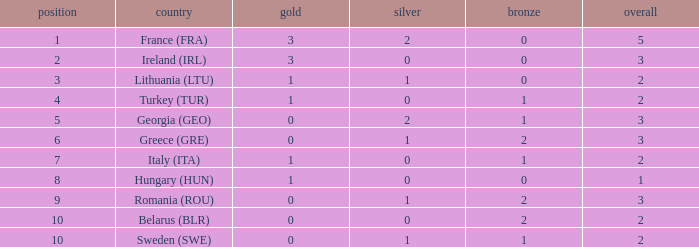What's the total when the gold is less than 0 and silver is less than 1? None. 